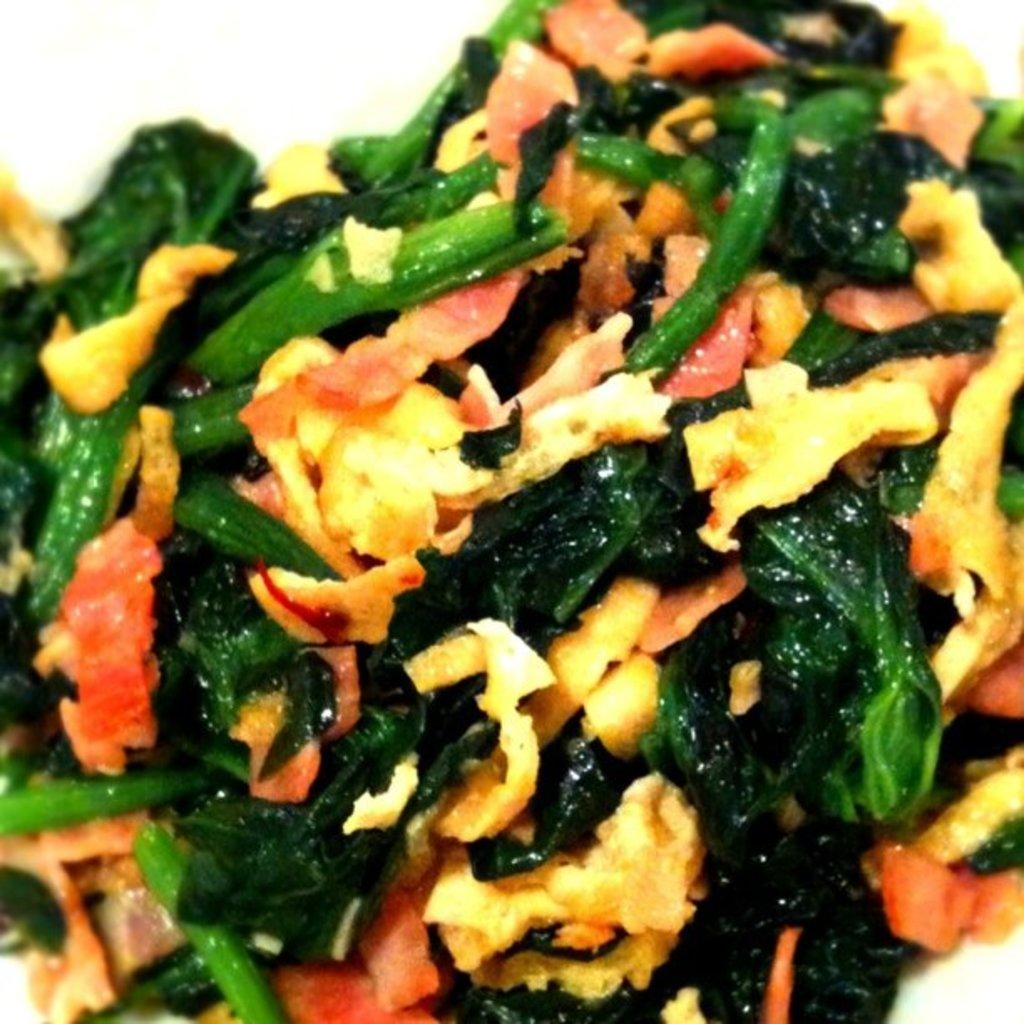What type of food is visible in the image? There are fried vegetables and other fried food items in the image. What color is the background of the image? The background of the image is white. How many sheep can be seen in the image? There are no sheep present in the image. What type of view is visible in the image? The image does not depict a view; it shows fried food items on a white background. Are there any sisters in the image? There is no reference to any people, let alone sisters, in the image. 